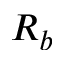Convert formula to latex. <formula><loc_0><loc_0><loc_500><loc_500>R _ { b }</formula> 